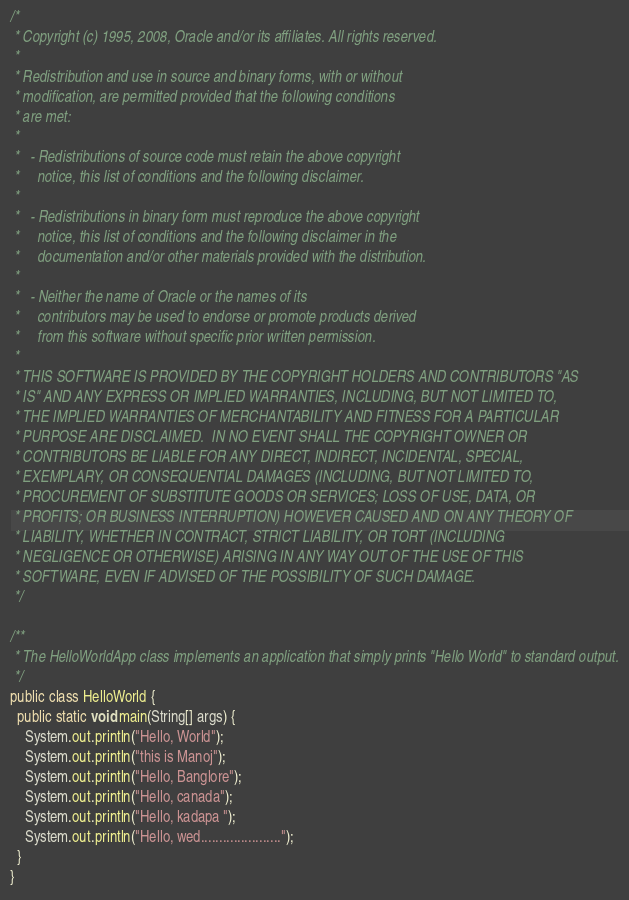<code> <loc_0><loc_0><loc_500><loc_500><_Java_>/*
 * Copyright (c) 1995, 2008, Oracle and/or its affiliates. All rights reserved.
 *
 * Redistribution and use in source and binary forms, with or without
 * modification, are permitted provided that the following conditions
 * are met:
 *
 *   - Redistributions of source code must retain the above copyright
 *     notice, this list of conditions and the following disclaimer.
 *
 *   - Redistributions in binary form must reproduce the above copyright
 *     notice, this list of conditions and the following disclaimer in the
 *     documentation and/or other materials provided with the distribution.
 *
 *   - Neither the name of Oracle or the names of its
 *     contributors may be used to endorse or promote products derived
 *     from this software without specific prior written permission.
 *
 * THIS SOFTWARE IS PROVIDED BY THE COPYRIGHT HOLDERS AND CONTRIBUTORS "AS
 * IS" AND ANY EXPRESS OR IMPLIED WARRANTIES, INCLUDING, BUT NOT LIMITED TO,
 * THE IMPLIED WARRANTIES OF MERCHANTABILITY AND FITNESS FOR A PARTICULAR
 * PURPOSE ARE DISCLAIMED.  IN NO EVENT SHALL THE COPYRIGHT OWNER OR
 * CONTRIBUTORS BE LIABLE FOR ANY DIRECT, INDIRECT, INCIDENTAL, SPECIAL,
 * EXEMPLARY, OR CONSEQUENTIAL DAMAGES (INCLUDING, BUT NOT LIMITED TO,
 * PROCUREMENT OF SUBSTITUTE GOODS OR SERVICES; LOSS OF USE, DATA, OR
 * PROFITS; OR BUSINESS INTERRUPTION) HOWEVER CAUSED AND ON ANY THEORY OF
 * LIABILITY, WHETHER IN CONTRACT, STRICT LIABILITY, OR TORT (INCLUDING
 * NEGLIGENCE OR OTHERWISE) ARISING IN ANY WAY OUT OF THE USE OF THIS
 * SOFTWARE, EVEN IF ADVISED OF THE POSSIBILITY OF SUCH DAMAGE.
 */ 

/** 
 * The HelloWorldApp class implements an application that simply prints "Hello World" to standard output.
 */
public class HelloWorld {
  public static void main(String[] args) {
    System.out.println("Hello, World");
    System.out.println("this is Manoj");
    System.out.println("Hello, Banglore");
    System.out.println("Hello, canada");
    System.out.println("Hello, kadapa ");
    System.out.println("Hello, wed......................");
  }
}
</code> 